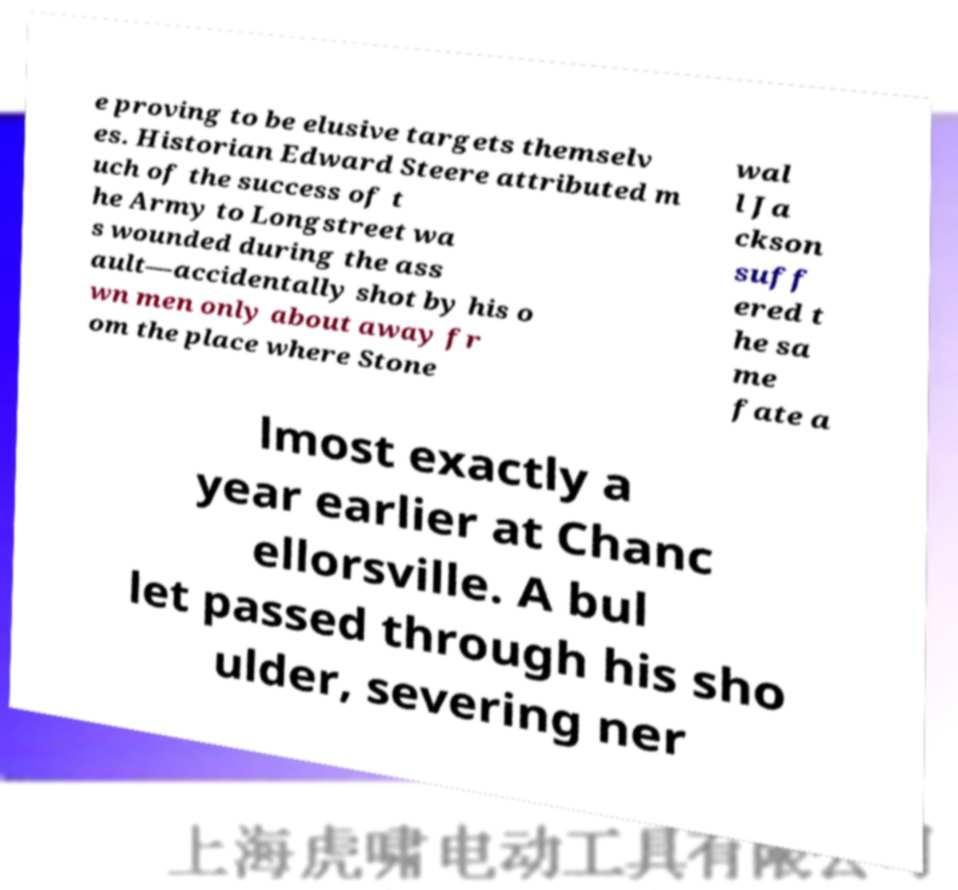Could you assist in decoding the text presented in this image and type it out clearly? e proving to be elusive targets themselv es. Historian Edward Steere attributed m uch of the success of t he Army to Longstreet wa s wounded during the ass ault—accidentally shot by his o wn men only about away fr om the place where Stone wal l Ja ckson suff ered t he sa me fate a lmost exactly a year earlier at Chanc ellorsville. A bul let passed through his sho ulder, severing ner 